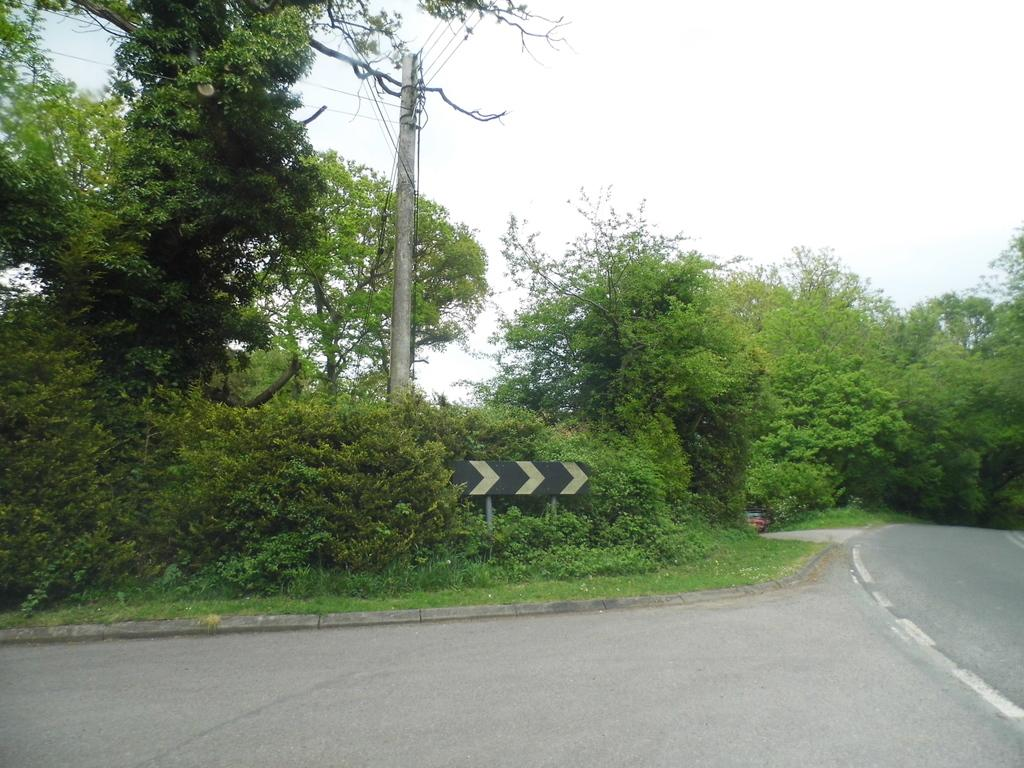What type of vegetation can be seen in the image? There are trees in the image. What is located at the bottom of the image? There is a road visible at the bottom of the image. What type of ground cover is present in the image? Grass is present in the image. What is in the center of the image? There is a pole in the center of the image, with a board attached to it. What can be seen in the background of the image? There are wires and the sky visible in the background of the image. Can you tell me how the girl is using the brake in the image? There is no girl or brake present in the image. What type of system is responsible for the wires in the background of the image? The image does not provide information about the system responsible for the wires in the background. 